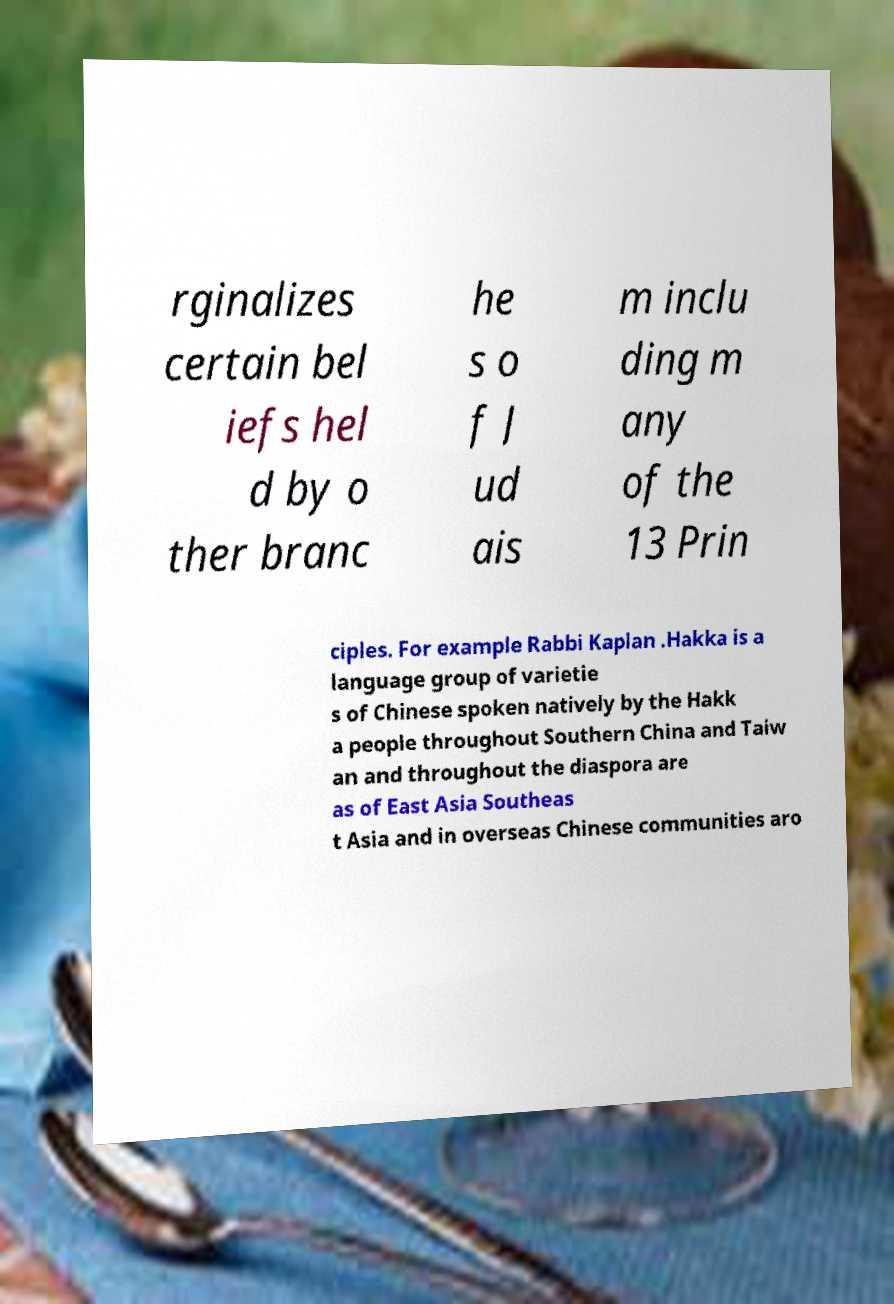For documentation purposes, I need the text within this image transcribed. Could you provide that? rginalizes certain bel iefs hel d by o ther branc he s o f J ud ais m inclu ding m any of the 13 Prin ciples. For example Rabbi Kaplan .Hakka is a language group of varietie s of Chinese spoken natively by the Hakk a people throughout Southern China and Taiw an and throughout the diaspora are as of East Asia Southeas t Asia and in overseas Chinese communities aro 